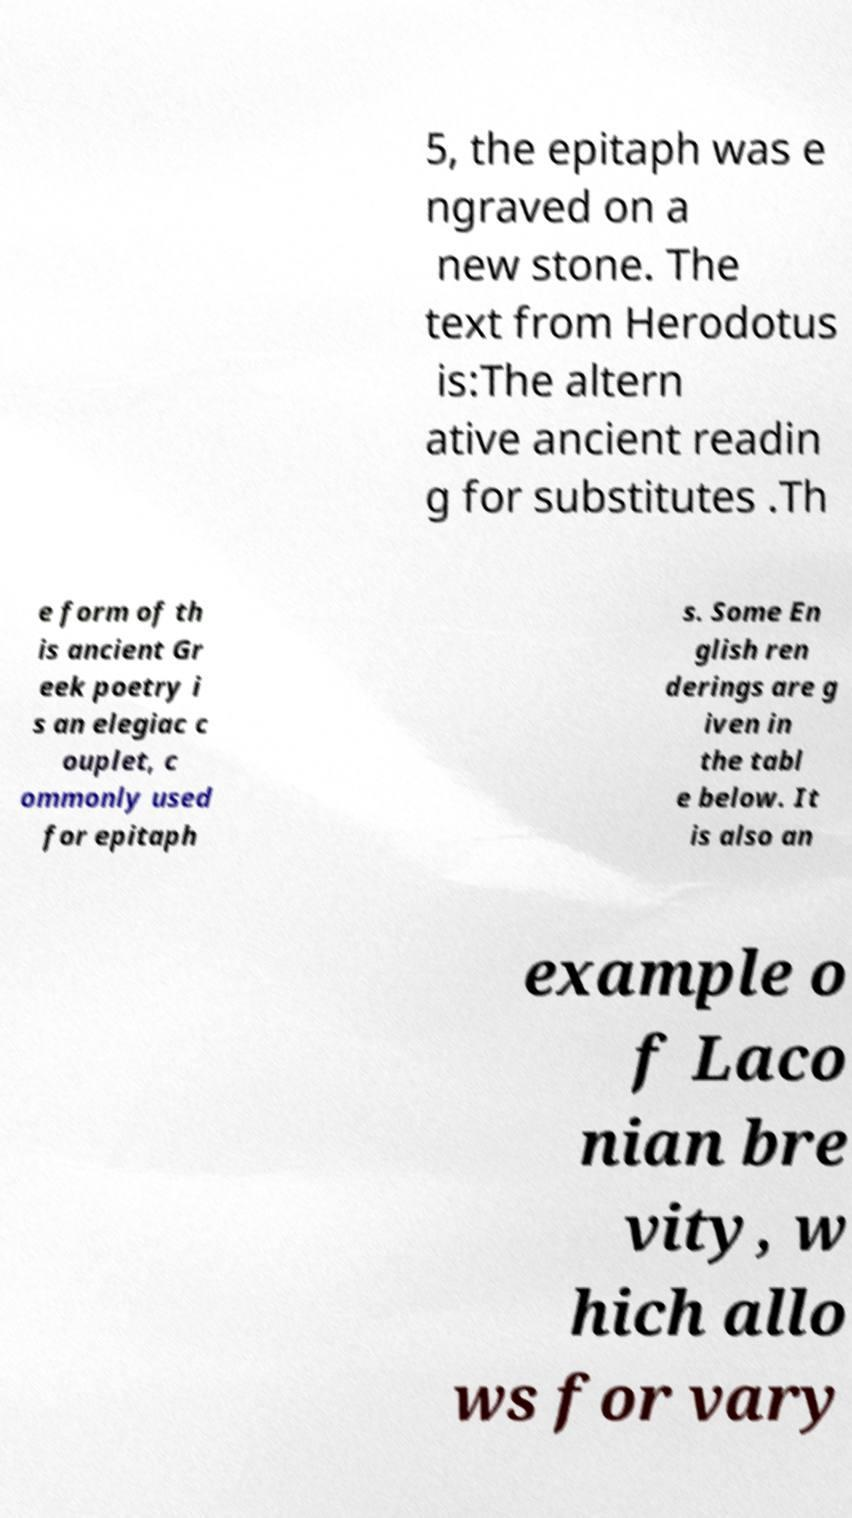Could you assist in decoding the text presented in this image and type it out clearly? 5, the epitaph was e ngraved on a new stone. The text from Herodotus is:The altern ative ancient readin g for substitutes .Th e form of th is ancient Gr eek poetry i s an elegiac c ouplet, c ommonly used for epitaph s. Some En glish ren derings are g iven in the tabl e below. It is also an example o f Laco nian bre vity, w hich allo ws for vary 